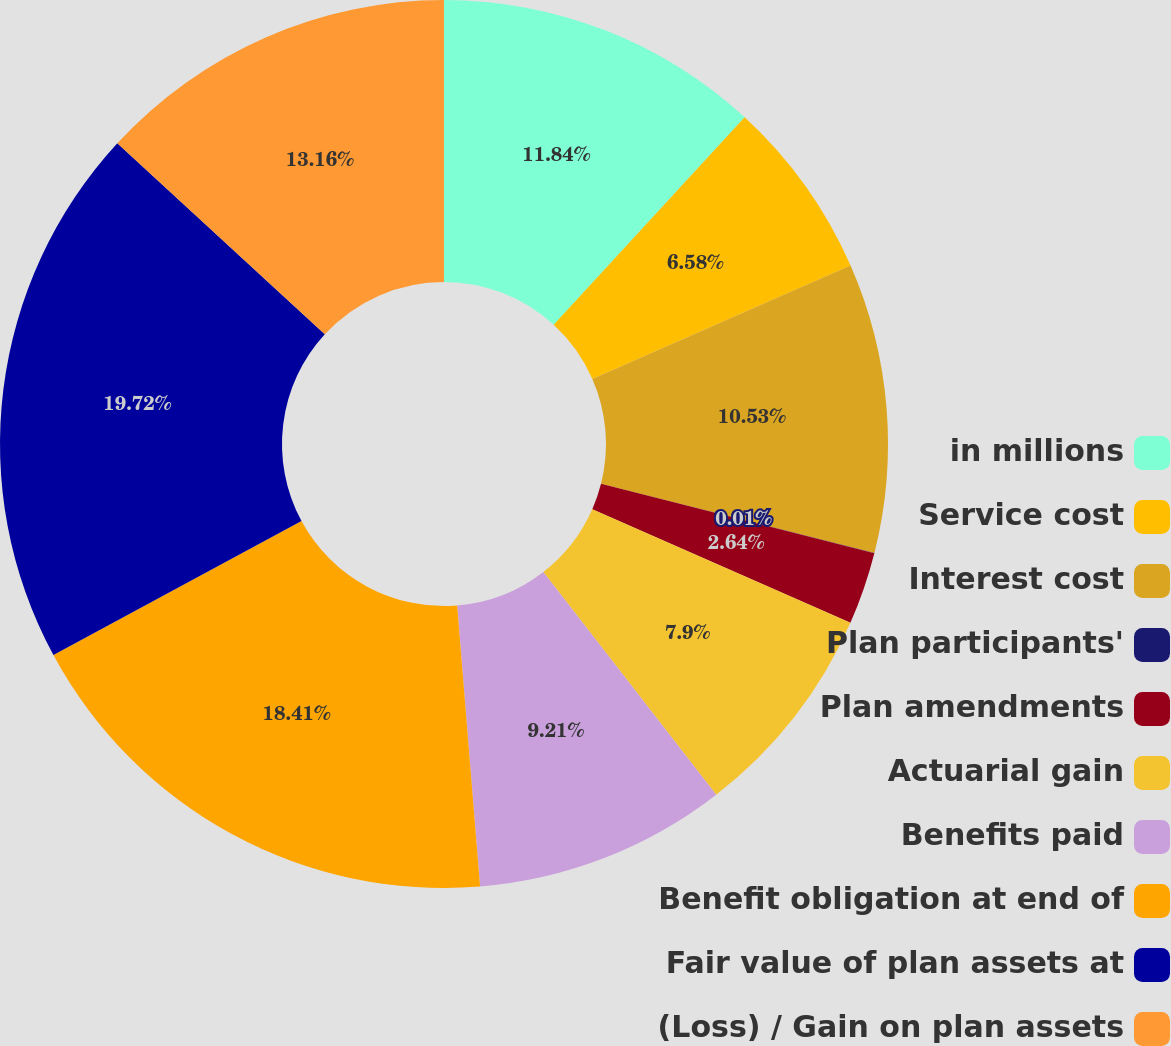<chart> <loc_0><loc_0><loc_500><loc_500><pie_chart><fcel>in millions<fcel>Service cost<fcel>Interest cost<fcel>Plan participants'<fcel>Plan amendments<fcel>Actuarial gain<fcel>Benefits paid<fcel>Benefit obligation at end of<fcel>Fair value of plan assets at<fcel>(Loss) / Gain on plan assets<nl><fcel>11.84%<fcel>6.58%<fcel>10.53%<fcel>0.01%<fcel>2.64%<fcel>7.9%<fcel>9.21%<fcel>18.41%<fcel>19.73%<fcel>13.16%<nl></chart> 